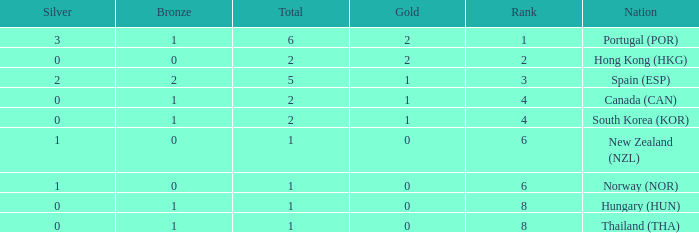What is the lowest Total containing a Bronze of 0 and Rank smaller than 2? None. 